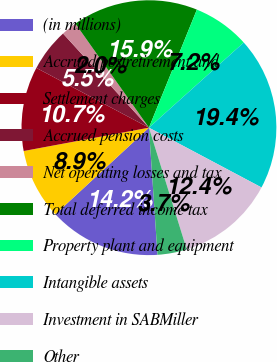Convert chart. <chart><loc_0><loc_0><loc_500><loc_500><pie_chart><fcel>(in millions)<fcel>Accrued postretirement and<fcel>Settlement charges<fcel>Accrued pension costs<fcel>Net operating losses and tax<fcel>Total deferred income tax<fcel>Property plant and equipment<fcel>Intangible assets<fcel>Investment in SABMiller<fcel>Other<nl><fcel>14.19%<fcel>8.95%<fcel>10.7%<fcel>5.46%<fcel>1.98%<fcel>15.93%<fcel>7.21%<fcel>19.42%<fcel>12.44%<fcel>3.72%<nl></chart> 